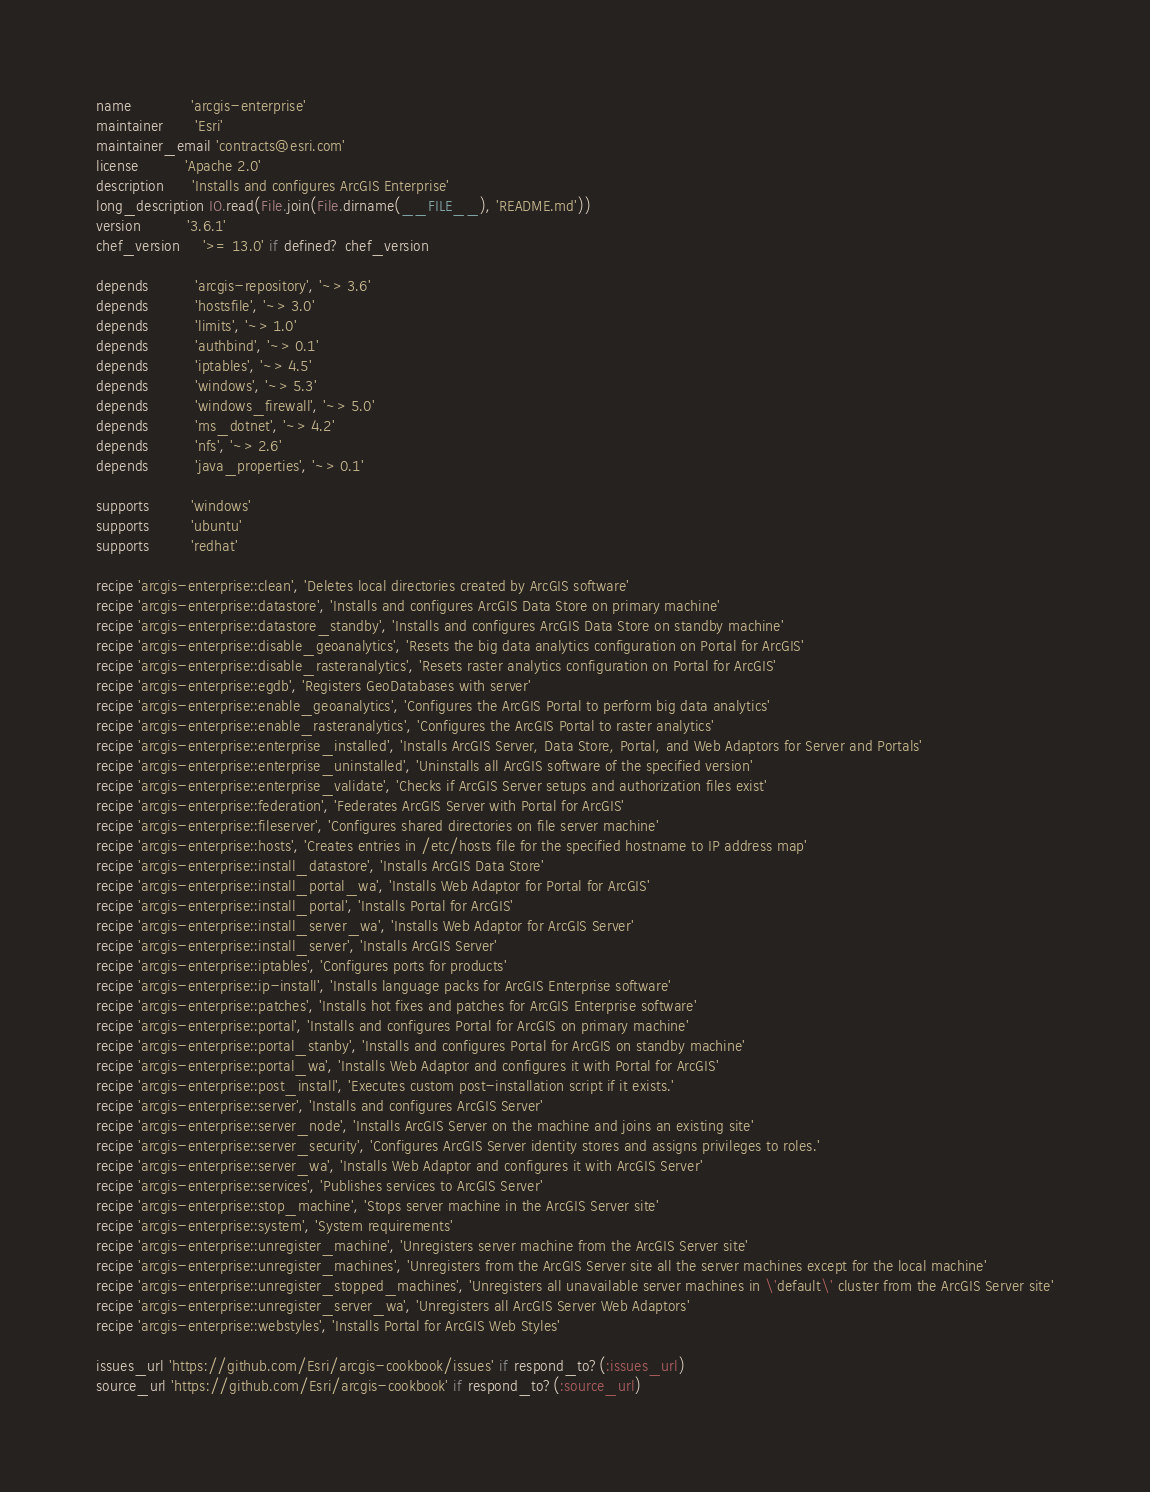<code> <loc_0><loc_0><loc_500><loc_500><_Ruby_>name             'arcgis-enterprise'
maintainer       'Esri'
maintainer_email 'contracts@esri.com'
license          'Apache 2.0'
description      'Installs and configures ArcGIS Enterprise'
long_description IO.read(File.join(File.dirname(__FILE__), 'README.md'))
version          '3.6.1'
chef_version     '>= 13.0' if defined? chef_version

depends          'arcgis-repository', '~> 3.6'
depends          'hostsfile', '~> 3.0'
depends          'limits', '~> 1.0'
depends          'authbind', '~> 0.1'
depends          'iptables', '~> 4.5'
depends          'windows', '~> 5.3'
depends          'windows_firewall', '~> 5.0'
depends          'ms_dotnet', '~> 4.2'
depends          'nfs', '~> 2.6'
depends          'java_properties', '~> 0.1'

supports         'windows'
supports         'ubuntu'
supports         'redhat'

recipe 'arcgis-enterprise::clean', 'Deletes local directories created by ArcGIS software'
recipe 'arcgis-enterprise::datastore', 'Installs and configures ArcGIS Data Store on primary machine'
recipe 'arcgis-enterprise::datastore_standby', 'Installs and configures ArcGIS Data Store on standby machine'
recipe 'arcgis-enterprise::disable_geoanalytics', 'Resets the big data analytics configuration on Portal for ArcGIS'
recipe 'arcgis-enterprise::disable_rasteranalytics', 'Resets raster analytics configuration on Portal for ArcGIS'
recipe 'arcgis-enterprise::egdb', 'Registers GeoDatabases with server'
recipe 'arcgis-enterprise::enable_geoanalytics', 'Configures the ArcGIS Portal to perform big data analytics'
recipe 'arcgis-enterprise::enable_rasteranalytics', 'Configures the ArcGIS Portal to raster analytics'
recipe 'arcgis-enterprise::enterprise_installed', 'Installs ArcGIS Server, Data Store, Portal, and Web Adaptors for Server and Portals'
recipe 'arcgis-enterprise::enterprise_uninstalled', 'Uninstalls all ArcGIS software of the specified version'
recipe 'arcgis-enterprise::enterprise_validate', 'Checks if ArcGIS Server setups and authorization files exist'
recipe 'arcgis-enterprise::federation', 'Federates ArcGIS Server with Portal for ArcGIS'
recipe 'arcgis-enterprise::fileserver', 'Configures shared directories on file server machine'
recipe 'arcgis-enterprise::hosts', 'Creates entries in /etc/hosts file for the specified hostname to IP address map'
recipe 'arcgis-enterprise::install_datastore', 'Installs ArcGIS Data Store'
recipe 'arcgis-enterprise::install_portal_wa', 'Installs Web Adaptor for Portal for ArcGIS'
recipe 'arcgis-enterprise::install_portal', 'Installs Portal for ArcGIS'
recipe 'arcgis-enterprise::install_server_wa', 'Installs Web Adaptor for ArcGIS Server'
recipe 'arcgis-enterprise::install_server', 'Installs ArcGIS Server'
recipe 'arcgis-enterprise::iptables', 'Configures ports for products'
recipe 'arcgis-enterprise::ip-install', 'Installs language packs for ArcGIS Enterprise software'
recipe 'arcgis-enterprise::patches', 'Installs hot fixes and patches for ArcGIS Enterprise software'
recipe 'arcgis-enterprise::portal', 'Installs and configures Portal for ArcGIS on primary machine'
recipe 'arcgis-enterprise::portal_stanby', 'Installs and configures Portal for ArcGIS on standby machine'
recipe 'arcgis-enterprise::portal_wa', 'Installs Web Adaptor and configures it with Portal for ArcGIS'
recipe 'arcgis-enterprise::post_install', 'Executes custom post-installation script if it exists.'
recipe 'arcgis-enterprise::server', 'Installs and configures ArcGIS Server'
recipe 'arcgis-enterprise::server_node', 'Installs ArcGIS Server on the machine and joins an existing site'
recipe 'arcgis-enterprise::server_security', 'Configures ArcGIS Server identity stores and assigns privileges to roles.'
recipe 'arcgis-enterprise::server_wa', 'Installs Web Adaptor and configures it with ArcGIS Server'
recipe 'arcgis-enterprise::services', 'Publishes services to ArcGIS Server'
recipe 'arcgis-enterprise::stop_machine', 'Stops server machine in the ArcGIS Server site'
recipe 'arcgis-enterprise::system', 'System requirements'
recipe 'arcgis-enterprise::unregister_machine', 'Unregisters server machine from the ArcGIS Server site'
recipe 'arcgis-enterprise::unregister_machines', 'Unregisters from the ArcGIS Server site all the server machines except for the local machine'
recipe 'arcgis-enterprise::unregister_stopped_machines', 'Unregisters all unavailable server machines in \'default\' cluster from the ArcGIS Server site'
recipe 'arcgis-enterprise::unregister_server_wa', 'Unregisters all ArcGIS Server Web Adaptors'
recipe 'arcgis-enterprise::webstyles', 'Installs Portal for ArcGIS Web Styles'

issues_url 'https://github.com/Esri/arcgis-cookbook/issues' if respond_to?(:issues_url)
source_url 'https://github.com/Esri/arcgis-cookbook' if respond_to?(:source_url)
</code> 